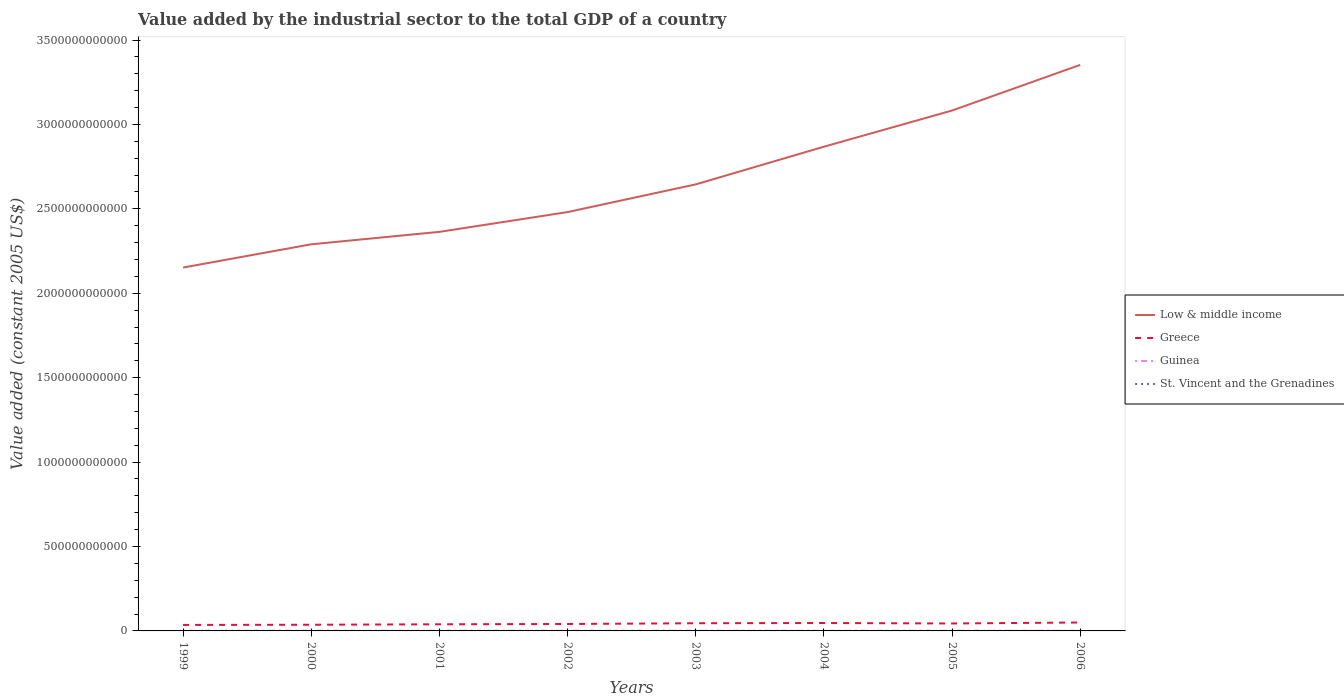How many different coloured lines are there?
Ensure brevity in your answer.  4. Does the line corresponding to Guinea intersect with the line corresponding to Greece?
Ensure brevity in your answer.  No. Is the number of lines equal to the number of legend labels?
Give a very brief answer. Yes. Across all years, what is the maximum value added by the industrial sector in Guinea?
Provide a succinct answer. 7.63e+08. In which year was the value added by the industrial sector in Guinea maximum?
Your answer should be compact. 1999. What is the total value added by the industrial sector in Guinea in the graph?
Give a very brief answer. -8.43e+07. What is the difference between the highest and the second highest value added by the industrial sector in St. Vincent and the Grenadines?
Ensure brevity in your answer.  2.52e+07. What is the difference between the highest and the lowest value added by the industrial sector in Greece?
Offer a terse response. 4. How many lines are there?
Your answer should be compact. 4. What is the difference between two consecutive major ticks on the Y-axis?
Your response must be concise. 5.00e+11. Are the values on the major ticks of Y-axis written in scientific E-notation?
Keep it short and to the point. No. How are the legend labels stacked?
Your response must be concise. Vertical. What is the title of the graph?
Your response must be concise. Value added by the industrial sector to the total GDP of a country. Does "Jamaica" appear as one of the legend labels in the graph?
Provide a short and direct response. No. What is the label or title of the X-axis?
Offer a terse response. Years. What is the label or title of the Y-axis?
Your answer should be very brief. Value added (constant 2005 US$). What is the Value added (constant 2005 US$) of Low & middle income in 1999?
Your response must be concise. 2.15e+12. What is the Value added (constant 2005 US$) in Greece in 1999?
Ensure brevity in your answer.  3.55e+1. What is the Value added (constant 2005 US$) of Guinea in 1999?
Your answer should be very brief. 7.63e+08. What is the Value added (constant 2005 US$) in St. Vincent and the Grenadines in 1999?
Ensure brevity in your answer.  7.55e+07. What is the Value added (constant 2005 US$) of Low & middle income in 2000?
Make the answer very short. 2.29e+12. What is the Value added (constant 2005 US$) in Greece in 2000?
Give a very brief answer. 3.66e+1. What is the Value added (constant 2005 US$) in Guinea in 2000?
Ensure brevity in your answer.  7.97e+08. What is the Value added (constant 2005 US$) in St. Vincent and the Grenadines in 2000?
Make the answer very short. 6.92e+07. What is the Value added (constant 2005 US$) of Low & middle income in 2001?
Your response must be concise. 2.36e+12. What is the Value added (constant 2005 US$) of Greece in 2001?
Your answer should be very brief. 3.93e+1. What is the Value added (constant 2005 US$) of Guinea in 2001?
Provide a succinct answer. 8.38e+08. What is the Value added (constant 2005 US$) of St. Vincent and the Grenadines in 2001?
Your answer should be compact. 7.03e+07. What is the Value added (constant 2005 US$) of Low & middle income in 2002?
Your answer should be compact. 2.48e+12. What is the Value added (constant 2005 US$) in Greece in 2002?
Provide a succinct answer. 4.10e+1. What is the Value added (constant 2005 US$) of Guinea in 2002?
Provide a short and direct response. 8.80e+08. What is the Value added (constant 2005 US$) in St. Vincent and the Grenadines in 2002?
Your response must be concise. 7.29e+07. What is the Value added (constant 2005 US$) of Low & middle income in 2003?
Your answer should be compact. 2.65e+12. What is the Value added (constant 2005 US$) of Greece in 2003?
Your answer should be very brief. 4.55e+1. What is the Value added (constant 2005 US$) in Guinea in 2003?
Your answer should be compact. 8.81e+08. What is the Value added (constant 2005 US$) in St. Vincent and the Grenadines in 2003?
Keep it short and to the point. 8.26e+07. What is the Value added (constant 2005 US$) of Low & middle income in 2004?
Provide a succinct answer. 2.87e+12. What is the Value added (constant 2005 US$) of Greece in 2004?
Offer a very short reply. 4.68e+1. What is the Value added (constant 2005 US$) of Guinea in 2004?
Give a very brief answer. 9.08e+08. What is the Value added (constant 2005 US$) of St. Vincent and the Grenadines in 2004?
Your answer should be compact. 8.74e+07. What is the Value added (constant 2005 US$) in Low & middle income in 2005?
Offer a terse response. 3.08e+12. What is the Value added (constant 2005 US$) in Greece in 2005?
Offer a very short reply. 4.41e+1. What is the Value added (constant 2005 US$) of Guinea in 2005?
Give a very brief answer. 9.42e+08. What is the Value added (constant 2005 US$) in St. Vincent and the Grenadines in 2005?
Provide a succinct answer. 9.02e+07. What is the Value added (constant 2005 US$) of Low & middle income in 2006?
Offer a terse response. 3.35e+12. What is the Value added (constant 2005 US$) in Greece in 2006?
Provide a short and direct response. 4.99e+1. What is the Value added (constant 2005 US$) in Guinea in 2006?
Offer a terse response. 9.63e+08. What is the Value added (constant 2005 US$) in St. Vincent and the Grenadines in 2006?
Keep it short and to the point. 9.45e+07. Across all years, what is the maximum Value added (constant 2005 US$) of Low & middle income?
Offer a very short reply. 3.35e+12. Across all years, what is the maximum Value added (constant 2005 US$) of Greece?
Your response must be concise. 4.99e+1. Across all years, what is the maximum Value added (constant 2005 US$) in Guinea?
Keep it short and to the point. 9.63e+08. Across all years, what is the maximum Value added (constant 2005 US$) in St. Vincent and the Grenadines?
Provide a short and direct response. 9.45e+07. Across all years, what is the minimum Value added (constant 2005 US$) of Low & middle income?
Your answer should be compact. 2.15e+12. Across all years, what is the minimum Value added (constant 2005 US$) in Greece?
Keep it short and to the point. 3.55e+1. Across all years, what is the minimum Value added (constant 2005 US$) of Guinea?
Offer a very short reply. 7.63e+08. Across all years, what is the minimum Value added (constant 2005 US$) in St. Vincent and the Grenadines?
Your answer should be very brief. 6.92e+07. What is the total Value added (constant 2005 US$) in Low & middle income in the graph?
Provide a short and direct response. 2.12e+13. What is the total Value added (constant 2005 US$) of Greece in the graph?
Give a very brief answer. 3.39e+11. What is the total Value added (constant 2005 US$) of Guinea in the graph?
Your answer should be compact. 6.97e+09. What is the total Value added (constant 2005 US$) in St. Vincent and the Grenadines in the graph?
Offer a terse response. 6.43e+08. What is the difference between the Value added (constant 2005 US$) in Low & middle income in 1999 and that in 2000?
Offer a terse response. -1.38e+11. What is the difference between the Value added (constant 2005 US$) of Greece in 1999 and that in 2000?
Provide a succinct answer. -1.05e+09. What is the difference between the Value added (constant 2005 US$) in Guinea in 1999 and that in 2000?
Keep it short and to the point. -3.36e+07. What is the difference between the Value added (constant 2005 US$) of St. Vincent and the Grenadines in 1999 and that in 2000?
Offer a terse response. 6.26e+06. What is the difference between the Value added (constant 2005 US$) in Low & middle income in 1999 and that in 2001?
Your answer should be very brief. -2.11e+11. What is the difference between the Value added (constant 2005 US$) in Greece in 1999 and that in 2001?
Offer a very short reply. -3.78e+09. What is the difference between the Value added (constant 2005 US$) of Guinea in 1999 and that in 2001?
Provide a succinct answer. -7.47e+07. What is the difference between the Value added (constant 2005 US$) of St. Vincent and the Grenadines in 1999 and that in 2001?
Your answer should be compact. 5.14e+06. What is the difference between the Value added (constant 2005 US$) in Low & middle income in 1999 and that in 2002?
Keep it short and to the point. -3.29e+11. What is the difference between the Value added (constant 2005 US$) in Greece in 1999 and that in 2002?
Give a very brief answer. -5.54e+09. What is the difference between the Value added (constant 2005 US$) of Guinea in 1999 and that in 2002?
Offer a terse response. -1.17e+08. What is the difference between the Value added (constant 2005 US$) of St. Vincent and the Grenadines in 1999 and that in 2002?
Your answer should be compact. 2.57e+06. What is the difference between the Value added (constant 2005 US$) of Low & middle income in 1999 and that in 2003?
Provide a short and direct response. -4.93e+11. What is the difference between the Value added (constant 2005 US$) of Greece in 1999 and that in 2003?
Your answer should be very brief. -9.99e+09. What is the difference between the Value added (constant 2005 US$) of Guinea in 1999 and that in 2003?
Your answer should be very brief. -1.18e+08. What is the difference between the Value added (constant 2005 US$) in St. Vincent and the Grenadines in 1999 and that in 2003?
Your answer should be very brief. -7.10e+06. What is the difference between the Value added (constant 2005 US$) of Low & middle income in 1999 and that in 2004?
Ensure brevity in your answer.  -7.16e+11. What is the difference between the Value added (constant 2005 US$) of Greece in 1999 and that in 2004?
Keep it short and to the point. -1.13e+1. What is the difference between the Value added (constant 2005 US$) in Guinea in 1999 and that in 2004?
Make the answer very short. -1.44e+08. What is the difference between the Value added (constant 2005 US$) of St. Vincent and the Grenadines in 1999 and that in 2004?
Keep it short and to the point. -1.19e+07. What is the difference between the Value added (constant 2005 US$) in Low & middle income in 1999 and that in 2005?
Provide a succinct answer. -9.30e+11. What is the difference between the Value added (constant 2005 US$) in Greece in 1999 and that in 2005?
Offer a very short reply. -8.61e+09. What is the difference between the Value added (constant 2005 US$) in Guinea in 1999 and that in 2005?
Ensure brevity in your answer.  -1.78e+08. What is the difference between the Value added (constant 2005 US$) of St. Vincent and the Grenadines in 1999 and that in 2005?
Your answer should be compact. -1.48e+07. What is the difference between the Value added (constant 2005 US$) in Low & middle income in 1999 and that in 2006?
Offer a terse response. -1.20e+12. What is the difference between the Value added (constant 2005 US$) in Greece in 1999 and that in 2006?
Your answer should be compact. -1.44e+1. What is the difference between the Value added (constant 2005 US$) in Guinea in 1999 and that in 2006?
Your answer should be very brief. -2.00e+08. What is the difference between the Value added (constant 2005 US$) in St. Vincent and the Grenadines in 1999 and that in 2006?
Give a very brief answer. -1.90e+07. What is the difference between the Value added (constant 2005 US$) in Low & middle income in 2000 and that in 2001?
Provide a succinct answer. -7.37e+1. What is the difference between the Value added (constant 2005 US$) in Greece in 2000 and that in 2001?
Make the answer very short. -2.73e+09. What is the difference between the Value added (constant 2005 US$) in Guinea in 2000 and that in 2001?
Your response must be concise. -4.10e+07. What is the difference between the Value added (constant 2005 US$) of St. Vincent and the Grenadines in 2000 and that in 2001?
Ensure brevity in your answer.  -1.12e+06. What is the difference between the Value added (constant 2005 US$) in Low & middle income in 2000 and that in 2002?
Your answer should be very brief. -1.91e+11. What is the difference between the Value added (constant 2005 US$) of Greece in 2000 and that in 2002?
Make the answer very short. -4.49e+09. What is the difference between the Value added (constant 2005 US$) in Guinea in 2000 and that in 2002?
Your answer should be very brief. -8.36e+07. What is the difference between the Value added (constant 2005 US$) in St. Vincent and the Grenadines in 2000 and that in 2002?
Give a very brief answer. -3.69e+06. What is the difference between the Value added (constant 2005 US$) in Low & middle income in 2000 and that in 2003?
Provide a short and direct response. -3.55e+11. What is the difference between the Value added (constant 2005 US$) in Greece in 2000 and that in 2003?
Your answer should be compact. -8.93e+09. What is the difference between the Value added (constant 2005 US$) in Guinea in 2000 and that in 2003?
Offer a terse response. -8.43e+07. What is the difference between the Value added (constant 2005 US$) of St. Vincent and the Grenadines in 2000 and that in 2003?
Offer a terse response. -1.34e+07. What is the difference between the Value added (constant 2005 US$) in Low & middle income in 2000 and that in 2004?
Ensure brevity in your answer.  -5.78e+11. What is the difference between the Value added (constant 2005 US$) of Greece in 2000 and that in 2004?
Provide a short and direct response. -1.03e+1. What is the difference between the Value added (constant 2005 US$) in Guinea in 2000 and that in 2004?
Ensure brevity in your answer.  -1.11e+08. What is the difference between the Value added (constant 2005 US$) in St. Vincent and the Grenadines in 2000 and that in 2004?
Your answer should be compact. -1.82e+07. What is the difference between the Value added (constant 2005 US$) in Low & middle income in 2000 and that in 2005?
Keep it short and to the point. -7.92e+11. What is the difference between the Value added (constant 2005 US$) of Greece in 2000 and that in 2005?
Make the answer very short. -7.56e+09. What is the difference between the Value added (constant 2005 US$) in Guinea in 2000 and that in 2005?
Provide a succinct answer. -1.45e+08. What is the difference between the Value added (constant 2005 US$) of St. Vincent and the Grenadines in 2000 and that in 2005?
Keep it short and to the point. -2.10e+07. What is the difference between the Value added (constant 2005 US$) in Low & middle income in 2000 and that in 2006?
Provide a short and direct response. -1.06e+12. What is the difference between the Value added (constant 2005 US$) of Greece in 2000 and that in 2006?
Offer a very short reply. -1.34e+1. What is the difference between the Value added (constant 2005 US$) of Guinea in 2000 and that in 2006?
Offer a very short reply. -1.66e+08. What is the difference between the Value added (constant 2005 US$) in St. Vincent and the Grenadines in 2000 and that in 2006?
Keep it short and to the point. -2.52e+07. What is the difference between the Value added (constant 2005 US$) in Low & middle income in 2001 and that in 2002?
Ensure brevity in your answer.  -1.17e+11. What is the difference between the Value added (constant 2005 US$) of Greece in 2001 and that in 2002?
Offer a terse response. -1.76e+09. What is the difference between the Value added (constant 2005 US$) of Guinea in 2001 and that in 2002?
Keep it short and to the point. -4.25e+07. What is the difference between the Value added (constant 2005 US$) of St. Vincent and the Grenadines in 2001 and that in 2002?
Your response must be concise. -2.58e+06. What is the difference between the Value added (constant 2005 US$) of Low & middle income in 2001 and that in 2003?
Your answer should be compact. -2.81e+11. What is the difference between the Value added (constant 2005 US$) of Greece in 2001 and that in 2003?
Your response must be concise. -6.21e+09. What is the difference between the Value added (constant 2005 US$) of Guinea in 2001 and that in 2003?
Keep it short and to the point. -4.33e+07. What is the difference between the Value added (constant 2005 US$) in St. Vincent and the Grenadines in 2001 and that in 2003?
Make the answer very short. -1.22e+07. What is the difference between the Value added (constant 2005 US$) of Low & middle income in 2001 and that in 2004?
Your response must be concise. -5.04e+11. What is the difference between the Value added (constant 2005 US$) in Greece in 2001 and that in 2004?
Offer a terse response. -7.56e+09. What is the difference between the Value added (constant 2005 US$) of Guinea in 2001 and that in 2004?
Give a very brief answer. -6.97e+07. What is the difference between the Value added (constant 2005 US$) in St. Vincent and the Grenadines in 2001 and that in 2004?
Your answer should be compact. -1.70e+07. What is the difference between the Value added (constant 2005 US$) of Low & middle income in 2001 and that in 2005?
Your answer should be compact. -7.19e+11. What is the difference between the Value added (constant 2005 US$) of Greece in 2001 and that in 2005?
Give a very brief answer. -4.83e+09. What is the difference between the Value added (constant 2005 US$) in Guinea in 2001 and that in 2005?
Give a very brief answer. -1.04e+08. What is the difference between the Value added (constant 2005 US$) of St. Vincent and the Grenadines in 2001 and that in 2005?
Your answer should be very brief. -1.99e+07. What is the difference between the Value added (constant 2005 US$) in Low & middle income in 2001 and that in 2006?
Offer a terse response. -9.89e+11. What is the difference between the Value added (constant 2005 US$) in Greece in 2001 and that in 2006?
Give a very brief answer. -1.06e+1. What is the difference between the Value added (constant 2005 US$) of Guinea in 2001 and that in 2006?
Your answer should be very brief. -1.25e+08. What is the difference between the Value added (constant 2005 US$) in St. Vincent and the Grenadines in 2001 and that in 2006?
Your answer should be very brief. -2.41e+07. What is the difference between the Value added (constant 2005 US$) of Low & middle income in 2002 and that in 2003?
Your answer should be compact. -1.64e+11. What is the difference between the Value added (constant 2005 US$) of Greece in 2002 and that in 2003?
Offer a very short reply. -4.45e+09. What is the difference between the Value added (constant 2005 US$) of Guinea in 2002 and that in 2003?
Give a very brief answer. -7.42e+05. What is the difference between the Value added (constant 2005 US$) of St. Vincent and the Grenadines in 2002 and that in 2003?
Make the answer very short. -9.67e+06. What is the difference between the Value added (constant 2005 US$) of Low & middle income in 2002 and that in 2004?
Make the answer very short. -3.87e+11. What is the difference between the Value added (constant 2005 US$) of Greece in 2002 and that in 2004?
Your answer should be compact. -5.80e+09. What is the difference between the Value added (constant 2005 US$) in Guinea in 2002 and that in 2004?
Make the answer very short. -2.71e+07. What is the difference between the Value added (constant 2005 US$) in St. Vincent and the Grenadines in 2002 and that in 2004?
Give a very brief answer. -1.45e+07. What is the difference between the Value added (constant 2005 US$) in Low & middle income in 2002 and that in 2005?
Provide a short and direct response. -6.02e+11. What is the difference between the Value added (constant 2005 US$) of Greece in 2002 and that in 2005?
Make the answer very short. -3.07e+09. What is the difference between the Value added (constant 2005 US$) in Guinea in 2002 and that in 2005?
Your response must be concise. -6.12e+07. What is the difference between the Value added (constant 2005 US$) in St. Vincent and the Grenadines in 2002 and that in 2005?
Offer a terse response. -1.73e+07. What is the difference between the Value added (constant 2005 US$) in Low & middle income in 2002 and that in 2006?
Offer a very short reply. -8.72e+11. What is the difference between the Value added (constant 2005 US$) in Greece in 2002 and that in 2006?
Ensure brevity in your answer.  -8.89e+09. What is the difference between the Value added (constant 2005 US$) in Guinea in 2002 and that in 2006?
Keep it short and to the point. -8.27e+07. What is the difference between the Value added (constant 2005 US$) of St. Vincent and the Grenadines in 2002 and that in 2006?
Give a very brief answer. -2.15e+07. What is the difference between the Value added (constant 2005 US$) of Low & middle income in 2003 and that in 2004?
Your response must be concise. -2.23e+11. What is the difference between the Value added (constant 2005 US$) of Greece in 2003 and that in 2004?
Your answer should be very brief. -1.35e+09. What is the difference between the Value added (constant 2005 US$) of Guinea in 2003 and that in 2004?
Keep it short and to the point. -2.64e+07. What is the difference between the Value added (constant 2005 US$) of St. Vincent and the Grenadines in 2003 and that in 2004?
Your answer should be compact. -4.79e+06. What is the difference between the Value added (constant 2005 US$) of Low & middle income in 2003 and that in 2005?
Provide a succinct answer. -4.37e+11. What is the difference between the Value added (constant 2005 US$) in Greece in 2003 and that in 2005?
Provide a succinct answer. 1.38e+09. What is the difference between the Value added (constant 2005 US$) in Guinea in 2003 and that in 2005?
Your answer should be very brief. -6.05e+07. What is the difference between the Value added (constant 2005 US$) in St. Vincent and the Grenadines in 2003 and that in 2005?
Ensure brevity in your answer.  -7.65e+06. What is the difference between the Value added (constant 2005 US$) of Low & middle income in 2003 and that in 2006?
Provide a succinct answer. -7.08e+11. What is the difference between the Value added (constant 2005 US$) in Greece in 2003 and that in 2006?
Make the answer very short. -4.44e+09. What is the difference between the Value added (constant 2005 US$) in Guinea in 2003 and that in 2006?
Your answer should be compact. -8.19e+07. What is the difference between the Value added (constant 2005 US$) of St. Vincent and the Grenadines in 2003 and that in 2006?
Offer a terse response. -1.19e+07. What is the difference between the Value added (constant 2005 US$) in Low & middle income in 2004 and that in 2005?
Give a very brief answer. -2.14e+11. What is the difference between the Value added (constant 2005 US$) in Greece in 2004 and that in 2005?
Your answer should be very brief. 2.73e+09. What is the difference between the Value added (constant 2005 US$) of Guinea in 2004 and that in 2005?
Provide a succinct answer. -3.41e+07. What is the difference between the Value added (constant 2005 US$) in St. Vincent and the Grenadines in 2004 and that in 2005?
Your answer should be very brief. -2.86e+06. What is the difference between the Value added (constant 2005 US$) in Low & middle income in 2004 and that in 2006?
Provide a short and direct response. -4.85e+11. What is the difference between the Value added (constant 2005 US$) in Greece in 2004 and that in 2006?
Provide a short and direct response. -3.09e+09. What is the difference between the Value added (constant 2005 US$) in Guinea in 2004 and that in 2006?
Make the answer very short. -5.55e+07. What is the difference between the Value added (constant 2005 US$) of St. Vincent and the Grenadines in 2004 and that in 2006?
Offer a terse response. -7.08e+06. What is the difference between the Value added (constant 2005 US$) of Low & middle income in 2005 and that in 2006?
Keep it short and to the point. -2.70e+11. What is the difference between the Value added (constant 2005 US$) in Greece in 2005 and that in 2006?
Your answer should be compact. -5.82e+09. What is the difference between the Value added (constant 2005 US$) of Guinea in 2005 and that in 2006?
Your answer should be compact. -2.14e+07. What is the difference between the Value added (constant 2005 US$) in St. Vincent and the Grenadines in 2005 and that in 2006?
Keep it short and to the point. -4.23e+06. What is the difference between the Value added (constant 2005 US$) of Low & middle income in 1999 and the Value added (constant 2005 US$) of Greece in 2000?
Ensure brevity in your answer.  2.12e+12. What is the difference between the Value added (constant 2005 US$) in Low & middle income in 1999 and the Value added (constant 2005 US$) in Guinea in 2000?
Your answer should be very brief. 2.15e+12. What is the difference between the Value added (constant 2005 US$) in Low & middle income in 1999 and the Value added (constant 2005 US$) in St. Vincent and the Grenadines in 2000?
Offer a very short reply. 2.15e+12. What is the difference between the Value added (constant 2005 US$) of Greece in 1999 and the Value added (constant 2005 US$) of Guinea in 2000?
Make the answer very short. 3.47e+1. What is the difference between the Value added (constant 2005 US$) in Greece in 1999 and the Value added (constant 2005 US$) in St. Vincent and the Grenadines in 2000?
Provide a succinct answer. 3.54e+1. What is the difference between the Value added (constant 2005 US$) of Guinea in 1999 and the Value added (constant 2005 US$) of St. Vincent and the Grenadines in 2000?
Provide a succinct answer. 6.94e+08. What is the difference between the Value added (constant 2005 US$) of Low & middle income in 1999 and the Value added (constant 2005 US$) of Greece in 2001?
Keep it short and to the point. 2.11e+12. What is the difference between the Value added (constant 2005 US$) in Low & middle income in 1999 and the Value added (constant 2005 US$) in Guinea in 2001?
Your answer should be compact. 2.15e+12. What is the difference between the Value added (constant 2005 US$) of Low & middle income in 1999 and the Value added (constant 2005 US$) of St. Vincent and the Grenadines in 2001?
Provide a short and direct response. 2.15e+12. What is the difference between the Value added (constant 2005 US$) in Greece in 1999 and the Value added (constant 2005 US$) in Guinea in 2001?
Provide a succinct answer. 3.47e+1. What is the difference between the Value added (constant 2005 US$) of Greece in 1999 and the Value added (constant 2005 US$) of St. Vincent and the Grenadines in 2001?
Provide a succinct answer. 3.54e+1. What is the difference between the Value added (constant 2005 US$) of Guinea in 1999 and the Value added (constant 2005 US$) of St. Vincent and the Grenadines in 2001?
Keep it short and to the point. 6.93e+08. What is the difference between the Value added (constant 2005 US$) of Low & middle income in 1999 and the Value added (constant 2005 US$) of Greece in 2002?
Offer a very short reply. 2.11e+12. What is the difference between the Value added (constant 2005 US$) of Low & middle income in 1999 and the Value added (constant 2005 US$) of Guinea in 2002?
Your answer should be compact. 2.15e+12. What is the difference between the Value added (constant 2005 US$) in Low & middle income in 1999 and the Value added (constant 2005 US$) in St. Vincent and the Grenadines in 2002?
Your answer should be very brief. 2.15e+12. What is the difference between the Value added (constant 2005 US$) of Greece in 1999 and the Value added (constant 2005 US$) of Guinea in 2002?
Make the answer very short. 3.46e+1. What is the difference between the Value added (constant 2005 US$) in Greece in 1999 and the Value added (constant 2005 US$) in St. Vincent and the Grenadines in 2002?
Your answer should be compact. 3.54e+1. What is the difference between the Value added (constant 2005 US$) in Guinea in 1999 and the Value added (constant 2005 US$) in St. Vincent and the Grenadines in 2002?
Offer a very short reply. 6.90e+08. What is the difference between the Value added (constant 2005 US$) of Low & middle income in 1999 and the Value added (constant 2005 US$) of Greece in 2003?
Offer a terse response. 2.11e+12. What is the difference between the Value added (constant 2005 US$) in Low & middle income in 1999 and the Value added (constant 2005 US$) in Guinea in 2003?
Make the answer very short. 2.15e+12. What is the difference between the Value added (constant 2005 US$) of Low & middle income in 1999 and the Value added (constant 2005 US$) of St. Vincent and the Grenadines in 2003?
Your answer should be compact. 2.15e+12. What is the difference between the Value added (constant 2005 US$) in Greece in 1999 and the Value added (constant 2005 US$) in Guinea in 2003?
Provide a short and direct response. 3.46e+1. What is the difference between the Value added (constant 2005 US$) of Greece in 1999 and the Value added (constant 2005 US$) of St. Vincent and the Grenadines in 2003?
Give a very brief answer. 3.54e+1. What is the difference between the Value added (constant 2005 US$) in Guinea in 1999 and the Value added (constant 2005 US$) in St. Vincent and the Grenadines in 2003?
Give a very brief answer. 6.81e+08. What is the difference between the Value added (constant 2005 US$) in Low & middle income in 1999 and the Value added (constant 2005 US$) in Greece in 2004?
Keep it short and to the point. 2.11e+12. What is the difference between the Value added (constant 2005 US$) of Low & middle income in 1999 and the Value added (constant 2005 US$) of Guinea in 2004?
Your answer should be very brief. 2.15e+12. What is the difference between the Value added (constant 2005 US$) in Low & middle income in 1999 and the Value added (constant 2005 US$) in St. Vincent and the Grenadines in 2004?
Give a very brief answer. 2.15e+12. What is the difference between the Value added (constant 2005 US$) in Greece in 1999 and the Value added (constant 2005 US$) in Guinea in 2004?
Give a very brief answer. 3.46e+1. What is the difference between the Value added (constant 2005 US$) of Greece in 1999 and the Value added (constant 2005 US$) of St. Vincent and the Grenadines in 2004?
Your response must be concise. 3.54e+1. What is the difference between the Value added (constant 2005 US$) of Guinea in 1999 and the Value added (constant 2005 US$) of St. Vincent and the Grenadines in 2004?
Your answer should be very brief. 6.76e+08. What is the difference between the Value added (constant 2005 US$) of Low & middle income in 1999 and the Value added (constant 2005 US$) of Greece in 2005?
Make the answer very short. 2.11e+12. What is the difference between the Value added (constant 2005 US$) of Low & middle income in 1999 and the Value added (constant 2005 US$) of Guinea in 2005?
Ensure brevity in your answer.  2.15e+12. What is the difference between the Value added (constant 2005 US$) in Low & middle income in 1999 and the Value added (constant 2005 US$) in St. Vincent and the Grenadines in 2005?
Provide a succinct answer. 2.15e+12. What is the difference between the Value added (constant 2005 US$) of Greece in 1999 and the Value added (constant 2005 US$) of Guinea in 2005?
Your answer should be very brief. 3.46e+1. What is the difference between the Value added (constant 2005 US$) of Greece in 1999 and the Value added (constant 2005 US$) of St. Vincent and the Grenadines in 2005?
Provide a succinct answer. 3.54e+1. What is the difference between the Value added (constant 2005 US$) of Guinea in 1999 and the Value added (constant 2005 US$) of St. Vincent and the Grenadines in 2005?
Provide a short and direct response. 6.73e+08. What is the difference between the Value added (constant 2005 US$) of Low & middle income in 1999 and the Value added (constant 2005 US$) of Greece in 2006?
Give a very brief answer. 2.10e+12. What is the difference between the Value added (constant 2005 US$) in Low & middle income in 1999 and the Value added (constant 2005 US$) in Guinea in 2006?
Offer a very short reply. 2.15e+12. What is the difference between the Value added (constant 2005 US$) of Low & middle income in 1999 and the Value added (constant 2005 US$) of St. Vincent and the Grenadines in 2006?
Offer a terse response. 2.15e+12. What is the difference between the Value added (constant 2005 US$) of Greece in 1999 and the Value added (constant 2005 US$) of Guinea in 2006?
Your answer should be very brief. 3.45e+1. What is the difference between the Value added (constant 2005 US$) in Greece in 1999 and the Value added (constant 2005 US$) in St. Vincent and the Grenadines in 2006?
Your response must be concise. 3.54e+1. What is the difference between the Value added (constant 2005 US$) in Guinea in 1999 and the Value added (constant 2005 US$) in St. Vincent and the Grenadines in 2006?
Offer a terse response. 6.69e+08. What is the difference between the Value added (constant 2005 US$) in Low & middle income in 2000 and the Value added (constant 2005 US$) in Greece in 2001?
Your answer should be compact. 2.25e+12. What is the difference between the Value added (constant 2005 US$) in Low & middle income in 2000 and the Value added (constant 2005 US$) in Guinea in 2001?
Provide a short and direct response. 2.29e+12. What is the difference between the Value added (constant 2005 US$) in Low & middle income in 2000 and the Value added (constant 2005 US$) in St. Vincent and the Grenadines in 2001?
Ensure brevity in your answer.  2.29e+12. What is the difference between the Value added (constant 2005 US$) of Greece in 2000 and the Value added (constant 2005 US$) of Guinea in 2001?
Ensure brevity in your answer.  3.57e+1. What is the difference between the Value added (constant 2005 US$) of Greece in 2000 and the Value added (constant 2005 US$) of St. Vincent and the Grenadines in 2001?
Ensure brevity in your answer.  3.65e+1. What is the difference between the Value added (constant 2005 US$) in Guinea in 2000 and the Value added (constant 2005 US$) in St. Vincent and the Grenadines in 2001?
Offer a very short reply. 7.26e+08. What is the difference between the Value added (constant 2005 US$) in Low & middle income in 2000 and the Value added (constant 2005 US$) in Greece in 2002?
Ensure brevity in your answer.  2.25e+12. What is the difference between the Value added (constant 2005 US$) in Low & middle income in 2000 and the Value added (constant 2005 US$) in Guinea in 2002?
Your answer should be compact. 2.29e+12. What is the difference between the Value added (constant 2005 US$) in Low & middle income in 2000 and the Value added (constant 2005 US$) in St. Vincent and the Grenadines in 2002?
Offer a very short reply. 2.29e+12. What is the difference between the Value added (constant 2005 US$) of Greece in 2000 and the Value added (constant 2005 US$) of Guinea in 2002?
Keep it short and to the point. 3.57e+1. What is the difference between the Value added (constant 2005 US$) of Greece in 2000 and the Value added (constant 2005 US$) of St. Vincent and the Grenadines in 2002?
Give a very brief answer. 3.65e+1. What is the difference between the Value added (constant 2005 US$) of Guinea in 2000 and the Value added (constant 2005 US$) of St. Vincent and the Grenadines in 2002?
Your response must be concise. 7.24e+08. What is the difference between the Value added (constant 2005 US$) in Low & middle income in 2000 and the Value added (constant 2005 US$) in Greece in 2003?
Your answer should be compact. 2.24e+12. What is the difference between the Value added (constant 2005 US$) of Low & middle income in 2000 and the Value added (constant 2005 US$) of Guinea in 2003?
Your response must be concise. 2.29e+12. What is the difference between the Value added (constant 2005 US$) in Low & middle income in 2000 and the Value added (constant 2005 US$) in St. Vincent and the Grenadines in 2003?
Keep it short and to the point. 2.29e+12. What is the difference between the Value added (constant 2005 US$) in Greece in 2000 and the Value added (constant 2005 US$) in Guinea in 2003?
Offer a very short reply. 3.57e+1. What is the difference between the Value added (constant 2005 US$) in Greece in 2000 and the Value added (constant 2005 US$) in St. Vincent and the Grenadines in 2003?
Provide a succinct answer. 3.65e+1. What is the difference between the Value added (constant 2005 US$) in Guinea in 2000 and the Value added (constant 2005 US$) in St. Vincent and the Grenadines in 2003?
Ensure brevity in your answer.  7.14e+08. What is the difference between the Value added (constant 2005 US$) of Low & middle income in 2000 and the Value added (constant 2005 US$) of Greece in 2004?
Give a very brief answer. 2.24e+12. What is the difference between the Value added (constant 2005 US$) of Low & middle income in 2000 and the Value added (constant 2005 US$) of Guinea in 2004?
Offer a very short reply. 2.29e+12. What is the difference between the Value added (constant 2005 US$) of Low & middle income in 2000 and the Value added (constant 2005 US$) of St. Vincent and the Grenadines in 2004?
Provide a succinct answer. 2.29e+12. What is the difference between the Value added (constant 2005 US$) of Greece in 2000 and the Value added (constant 2005 US$) of Guinea in 2004?
Make the answer very short. 3.57e+1. What is the difference between the Value added (constant 2005 US$) of Greece in 2000 and the Value added (constant 2005 US$) of St. Vincent and the Grenadines in 2004?
Your answer should be compact. 3.65e+1. What is the difference between the Value added (constant 2005 US$) of Guinea in 2000 and the Value added (constant 2005 US$) of St. Vincent and the Grenadines in 2004?
Ensure brevity in your answer.  7.09e+08. What is the difference between the Value added (constant 2005 US$) of Low & middle income in 2000 and the Value added (constant 2005 US$) of Greece in 2005?
Keep it short and to the point. 2.25e+12. What is the difference between the Value added (constant 2005 US$) of Low & middle income in 2000 and the Value added (constant 2005 US$) of Guinea in 2005?
Your answer should be very brief. 2.29e+12. What is the difference between the Value added (constant 2005 US$) of Low & middle income in 2000 and the Value added (constant 2005 US$) of St. Vincent and the Grenadines in 2005?
Provide a succinct answer. 2.29e+12. What is the difference between the Value added (constant 2005 US$) in Greece in 2000 and the Value added (constant 2005 US$) in Guinea in 2005?
Keep it short and to the point. 3.56e+1. What is the difference between the Value added (constant 2005 US$) in Greece in 2000 and the Value added (constant 2005 US$) in St. Vincent and the Grenadines in 2005?
Provide a short and direct response. 3.65e+1. What is the difference between the Value added (constant 2005 US$) in Guinea in 2000 and the Value added (constant 2005 US$) in St. Vincent and the Grenadines in 2005?
Offer a terse response. 7.07e+08. What is the difference between the Value added (constant 2005 US$) in Low & middle income in 2000 and the Value added (constant 2005 US$) in Greece in 2006?
Offer a terse response. 2.24e+12. What is the difference between the Value added (constant 2005 US$) in Low & middle income in 2000 and the Value added (constant 2005 US$) in Guinea in 2006?
Your answer should be compact. 2.29e+12. What is the difference between the Value added (constant 2005 US$) of Low & middle income in 2000 and the Value added (constant 2005 US$) of St. Vincent and the Grenadines in 2006?
Provide a short and direct response. 2.29e+12. What is the difference between the Value added (constant 2005 US$) in Greece in 2000 and the Value added (constant 2005 US$) in Guinea in 2006?
Your response must be concise. 3.56e+1. What is the difference between the Value added (constant 2005 US$) of Greece in 2000 and the Value added (constant 2005 US$) of St. Vincent and the Grenadines in 2006?
Offer a terse response. 3.65e+1. What is the difference between the Value added (constant 2005 US$) in Guinea in 2000 and the Value added (constant 2005 US$) in St. Vincent and the Grenadines in 2006?
Offer a terse response. 7.02e+08. What is the difference between the Value added (constant 2005 US$) of Low & middle income in 2001 and the Value added (constant 2005 US$) of Greece in 2002?
Keep it short and to the point. 2.32e+12. What is the difference between the Value added (constant 2005 US$) in Low & middle income in 2001 and the Value added (constant 2005 US$) in Guinea in 2002?
Your response must be concise. 2.36e+12. What is the difference between the Value added (constant 2005 US$) in Low & middle income in 2001 and the Value added (constant 2005 US$) in St. Vincent and the Grenadines in 2002?
Ensure brevity in your answer.  2.36e+12. What is the difference between the Value added (constant 2005 US$) in Greece in 2001 and the Value added (constant 2005 US$) in Guinea in 2002?
Offer a terse response. 3.84e+1. What is the difference between the Value added (constant 2005 US$) of Greece in 2001 and the Value added (constant 2005 US$) of St. Vincent and the Grenadines in 2002?
Offer a terse response. 3.92e+1. What is the difference between the Value added (constant 2005 US$) in Guinea in 2001 and the Value added (constant 2005 US$) in St. Vincent and the Grenadines in 2002?
Your answer should be compact. 7.65e+08. What is the difference between the Value added (constant 2005 US$) in Low & middle income in 2001 and the Value added (constant 2005 US$) in Greece in 2003?
Ensure brevity in your answer.  2.32e+12. What is the difference between the Value added (constant 2005 US$) of Low & middle income in 2001 and the Value added (constant 2005 US$) of Guinea in 2003?
Your response must be concise. 2.36e+12. What is the difference between the Value added (constant 2005 US$) in Low & middle income in 2001 and the Value added (constant 2005 US$) in St. Vincent and the Grenadines in 2003?
Make the answer very short. 2.36e+12. What is the difference between the Value added (constant 2005 US$) in Greece in 2001 and the Value added (constant 2005 US$) in Guinea in 2003?
Provide a short and direct response. 3.84e+1. What is the difference between the Value added (constant 2005 US$) in Greece in 2001 and the Value added (constant 2005 US$) in St. Vincent and the Grenadines in 2003?
Keep it short and to the point. 3.92e+1. What is the difference between the Value added (constant 2005 US$) in Guinea in 2001 and the Value added (constant 2005 US$) in St. Vincent and the Grenadines in 2003?
Your response must be concise. 7.55e+08. What is the difference between the Value added (constant 2005 US$) of Low & middle income in 2001 and the Value added (constant 2005 US$) of Greece in 2004?
Offer a terse response. 2.32e+12. What is the difference between the Value added (constant 2005 US$) of Low & middle income in 2001 and the Value added (constant 2005 US$) of Guinea in 2004?
Make the answer very short. 2.36e+12. What is the difference between the Value added (constant 2005 US$) of Low & middle income in 2001 and the Value added (constant 2005 US$) of St. Vincent and the Grenadines in 2004?
Your answer should be very brief. 2.36e+12. What is the difference between the Value added (constant 2005 US$) in Greece in 2001 and the Value added (constant 2005 US$) in Guinea in 2004?
Give a very brief answer. 3.84e+1. What is the difference between the Value added (constant 2005 US$) of Greece in 2001 and the Value added (constant 2005 US$) of St. Vincent and the Grenadines in 2004?
Offer a terse response. 3.92e+1. What is the difference between the Value added (constant 2005 US$) in Guinea in 2001 and the Value added (constant 2005 US$) in St. Vincent and the Grenadines in 2004?
Provide a succinct answer. 7.50e+08. What is the difference between the Value added (constant 2005 US$) in Low & middle income in 2001 and the Value added (constant 2005 US$) in Greece in 2005?
Offer a terse response. 2.32e+12. What is the difference between the Value added (constant 2005 US$) of Low & middle income in 2001 and the Value added (constant 2005 US$) of Guinea in 2005?
Give a very brief answer. 2.36e+12. What is the difference between the Value added (constant 2005 US$) of Low & middle income in 2001 and the Value added (constant 2005 US$) of St. Vincent and the Grenadines in 2005?
Make the answer very short. 2.36e+12. What is the difference between the Value added (constant 2005 US$) in Greece in 2001 and the Value added (constant 2005 US$) in Guinea in 2005?
Offer a very short reply. 3.83e+1. What is the difference between the Value added (constant 2005 US$) in Greece in 2001 and the Value added (constant 2005 US$) in St. Vincent and the Grenadines in 2005?
Offer a terse response. 3.92e+1. What is the difference between the Value added (constant 2005 US$) in Guinea in 2001 and the Value added (constant 2005 US$) in St. Vincent and the Grenadines in 2005?
Provide a short and direct response. 7.48e+08. What is the difference between the Value added (constant 2005 US$) in Low & middle income in 2001 and the Value added (constant 2005 US$) in Greece in 2006?
Your answer should be compact. 2.31e+12. What is the difference between the Value added (constant 2005 US$) of Low & middle income in 2001 and the Value added (constant 2005 US$) of Guinea in 2006?
Your answer should be very brief. 2.36e+12. What is the difference between the Value added (constant 2005 US$) in Low & middle income in 2001 and the Value added (constant 2005 US$) in St. Vincent and the Grenadines in 2006?
Provide a short and direct response. 2.36e+12. What is the difference between the Value added (constant 2005 US$) in Greece in 2001 and the Value added (constant 2005 US$) in Guinea in 2006?
Provide a short and direct response. 3.83e+1. What is the difference between the Value added (constant 2005 US$) of Greece in 2001 and the Value added (constant 2005 US$) of St. Vincent and the Grenadines in 2006?
Offer a terse response. 3.92e+1. What is the difference between the Value added (constant 2005 US$) of Guinea in 2001 and the Value added (constant 2005 US$) of St. Vincent and the Grenadines in 2006?
Your response must be concise. 7.43e+08. What is the difference between the Value added (constant 2005 US$) of Low & middle income in 2002 and the Value added (constant 2005 US$) of Greece in 2003?
Provide a succinct answer. 2.44e+12. What is the difference between the Value added (constant 2005 US$) of Low & middle income in 2002 and the Value added (constant 2005 US$) of Guinea in 2003?
Your response must be concise. 2.48e+12. What is the difference between the Value added (constant 2005 US$) in Low & middle income in 2002 and the Value added (constant 2005 US$) in St. Vincent and the Grenadines in 2003?
Give a very brief answer. 2.48e+12. What is the difference between the Value added (constant 2005 US$) in Greece in 2002 and the Value added (constant 2005 US$) in Guinea in 2003?
Your response must be concise. 4.02e+1. What is the difference between the Value added (constant 2005 US$) in Greece in 2002 and the Value added (constant 2005 US$) in St. Vincent and the Grenadines in 2003?
Ensure brevity in your answer.  4.10e+1. What is the difference between the Value added (constant 2005 US$) in Guinea in 2002 and the Value added (constant 2005 US$) in St. Vincent and the Grenadines in 2003?
Give a very brief answer. 7.98e+08. What is the difference between the Value added (constant 2005 US$) of Low & middle income in 2002 and the Value added (constant 2005 US$) of Greece in 2004?
Offer a terse response. 2.43e+12. What is the difference between the Value added (constant 2005 US$) of Low & middle income in 2002 and the Value added (constant 2005 US$) of Guinea in 2004?
Offer a terse response. 2.48e+12. What is the difference between the Value added (constant 2005 US$) of Low & middle income in 2002 and the Value added (constant 2005 US$) of St. Vincent and the Grenadines in 2004?
Make the answer very short. 2.48e+12. What is the difference between the Value added (constant 2005 US$) of Greece in 2002 and the Value added (constant 2005 US$) of Guinea in 2004?
Ensure brevity in your answer.  4.01e+1. What is the difference between the Value added (constant 2005 US$) of Greece in 2002 and the Value added (constant 2005 US$) of St. Vincent and the Grenadines in 2004?
Give a very brief answer. 4.10e+1. What is the difference between the Value added (constant 2005 US$) of Guinea in 2002 and the Value added (constant 2005 US$) of St. Vincent and the Grenadines in 2004?
Give a very brief answer. 7.93e+08. What is the difference between the Value added (constant 2005 US$) in Low & middle income in 2002 and the Value added (constant 2005 US$) in Greece in 2005?
Give a very brief answer. 2.44e+12. What is the difference between the Value added (constant 2005 US$) in Low & middle income in 2002 and the Value added (constant 2005 US$) in Guinea in 2005?
Make the answer very short. 2.48e+12. What is the difference between the Value added (constant 2005 US$) of Low & middle income in 2002 and the Value added (constant 2005 US$) of St. Vincent and the Grenadines in 2005?
Provide a succinct answer. 2.48e+12. What is the difference between the Value added (constant 2005 US$) in Greece in 2002 and the Value added (constant 2005 US$) in Guinea in 2005?
Offer a very short reply. 4.01e+1. What is the difference between the Value added (constant 2005 US$) of Greece in 2002 and the Value added (constant 2005 US$) of St. Vincent and the Grenadines in 2005?
Your answer should be very brief. 4.10e+1. What is the difference between the Value added (constant 2005 US$) in Guinea in 2002 and the Value added (constant 2005 US$) in St. Vincent and the Grenadines in 2005?
Your answer should be compact. 7.90e+08. What is the difference between the Value added (constant 2005 US$) in Low & middle income in 2002 and the Value added (constant 2005 US$) in Greece in 2006?
Provide a succinct answer. 2.43e+12. What is the difference between the Value added (constant 2005 US$) in Low & middle income in 2002 and the Value added (constant 2005 US$) in Guinea in 2006?
Your response must be concise. 2.48e+12. What is the difference between the Value added (constant 2005 US$) in Low & middle income in 2002 and the Value added (constant 2005 US$) in St. Vincent and the Grenadines in 2006?
Ensure brevity in your answer.  2.48e+12. What is the difference between the Value added (constant 2005 US$) of Greece in 2002 and the Value added (constant 2005 US$) of Guinea in 2006?
Keep it short and to the point. 4.01e+1. What is the difference between the Value added (constant 2005 US$) of Greece in 2002 and the Value added (constant 2005 US$) of St. Vincent and the Grenadines in 2006?
Make the answer very short. 4.10e+1. What is the difference between the Value added (constant 2005 US$) of Guinea in 2002 and the Value added (constant 2005 US$) of St. Vincent and the Grenadines in 2006?
Give a very brief answer. 7.86e+08. What is the difference between the Value added (constant 2005 US$) in Low & middle income in 2003 and the Value added (constant 2005 US$) in Greece in 2004?
Your answer should be very brief. 2.60e+12. What is the difference between the Value added (constant 2005 US$) of Low & middle income in 2003 and the Value added (constant 2005 US$) of Guinea in 2004?
Your answer should be very brief. 2.64e+12. What is the difference between the Value added (constant 2005 US$) of Low & middle income in 2003 and the Value added (constant 2005 US$) of St. Vincent and the Grenadines in 2004?
Keep it short and to the point. 2.65e+12. What is the difference between the Value added (constant 2005 US$) of Greece in 2003 and the Value added (constant 2005 US$) of Guinea in 2004?
Your answer should be compact. 4.46e+1. What is the difference between the Value added (constant 2005 US$) of Greece in 2003 and the Value added (constant 2005 US$) of St. Vincent and the Grenadines in 2004?
Make the answer very short. 4.54e+1. What is the difference between the Value added (constant 2005 US$) of Guinea in 2003 and the Value added (constant 2005 US$) of St. Vincent and the Grenadines in 2004?
Ensure brevity in your answer.  7.94e+08. What is the difference between the Value added (constant 2005 US$) of Low & middle income in 2003 and the Value added (constant 2005 US$) of Greece in 2005?
Give a very brief answer. 2.60e+12. What is the difference between the Value added (constant 2005 US$) of Low & middle income in 2003 and the Value added (constant 2005 US$) of Guinea in 2005?
Provide a short and direct response. 2.64e+12. What is the difference between the Value added (constant 2005 US$) of Low & middle income in 2003 and the Value added (constant 2005 US$) of St. Vincent and the Grenadines in 2005?
Your answer should be compact. 2.65e+12. What is the difference between the Value added (constant 2005 US$) of Greece in 2003 and the Value added (constant 2005 US$) of Guinea in 2005?
Your answer should be compact. 4.46e+1. What is the difference between the Value added (constant 2005 US$) in Greece in 2003 and the Value added (constant 2005 US$) in St. Vincent and the Grenadines in 2005?
Your answer should be compact. 4.54e+1. What is the difference between the Value added (constant 2005 US$) of Guinea in 2003 and the Value added (constant 2005 US$) of St. Vincent and the Grenadines in 2005?
Offer a terse response. 7.91e+08. What is the difference between the Value added (constant 2005 US$) in Low & middle income in 2003 and the Value added (constant 2005 US$) in Greece in 2006?
Your answer should be very brief. 2.60e+12. What is the difference between the Value added (constant 2005 US$) of Low & middle income in 2003 and the Value added (constant 2005 US$) of Guinea in 2006?
Provide a succinct answer. 2.64e+12. What is the difference between the Value added (constant 2005 US$) in Low & middle income in 2003 and the Value added (constant 2005 US$) in St. Vincent and the Grenadines in 2006?
Your answer should be compact. 2.65e+12. What is the difference between the Value added (constant 2005 US$) in Greece in 2003 and the Value added (constant 2005 US$) in Guinea in 2006?
Your response must be concise. 4.45e+1. What is the difference between the Value added (constant 2005 US$) in Greece in 2003 and the Value added (constant 2005 US$) in St. Vincent and the Grenadines in 2006?
Offer a terse response. 4.54e+1. What is the difference between the Value added (constant 2005 US$) of Guinea in 2003 and the Value added (constant 2005 US$) of St. Vincent and the Grenadines in 2006?
Your response must be concise. 7.87e+08. What is the difference between the Value added (constant 2005 US$) in Low & middle income in 2004 and the Value added (constant 2005 US$) in Greece in 2005?
Ensure brevity in your answer.  2.82e+12. What is the difference between the Value added (constant 2005 US$) in Low & middle income in 2004 and the Value added (constant 2005 US$) in Guinea in 2005?
Your response must be concise. 2.87e+12. What is the difference between the Value added (constant 2005 US$) in Low & middle income in 2004 and the Value added (constant 2005 US$) in St. Vincent and the Grenadines in 2005?
Make the answer very short. 2.87e+12. What is the difference between the Value added (constant 2005 US$) in Greece in 2004 and the Value added (constant 2005 US$) in Guinea in 2005?
Your answer should be compact. 4.59e+1. What is the difference between the Value added (constant 2005 US$) in Greece in 2004 and the Value added (constant 2005 US$) in St. Vincent and the Grenadines in 2005?
Your answer should be very brief. 4.68e+1. What is the difference between the Value added (constant 2005 US$) of Guinea in 2004 and the Value added (constant 2005 US$) of St. Vincent and the Grenadines in 2005?
Give a very brief answer. 8.17e+08. What is the difference between the Value added (constant 2005 US$) of Low & middle income in 2004 and the Value added (constant 2005 US$) of Greece in 2006?
Ensure brevity in your answer.  2.82e+12. What is the difference between the Value added (constant 2005 US$) in Low & middle income in 2004 and the Value added (constant 2005 US$) in Guinea in 2006?
Your response must be concise. 2.87e+12. What is the difference between the Value added (constant 2005 US$) of Low & middle income in 2004 and the Value added (constant 2005 US$) of St. Vincent and the Grenadines in 2006?
Give a very brief answer. 2.87e+12. What is the difference between the Value added (constant 2005 US$) in Greece in 2004 and the Value added (constant 2005 US$) in Guinea in 2006?
Provide a short and direct response. 4.59e+1. What is the difference between the Value added (constant 2005 US$) in Greece in 2004 and the Value added (constant 2005 US$) in St. Vincent and the Grenadines in 2006?
Provide a succinct answer. 4.68e+1. What is the difference between the Value added (constant 2005 US$) in Guinea in 2004 and the Value added (constant 2005 US$) in St. Vincent and the Grenadines in 2006?
Provide a succinct answer. 8.13e+08. What is the difference between the Value added (constant 2005 US$) in Low & middle income in 2005 and the Value added (constant 2005 US$) in Greece in 2006?
Your response must be concise. 3.03e+12. What is the difference between the Value added (constant 2005 US$) in Low & middle income in 2005 and the Value added (constant 2005 US$) in Guinea in 2006?
Offer a very short reply. 3.08e+12. What is the difference between the Value added (constant 2005 US$) in Low & middle income in 2005 and the Value added (constant 2005 US$) in St. Vincent and the Grenadines in 2006?
Provide a short and direct response. 3.08e+12. What is the difference between the Value added (constant 2005 US$) in Greece in 2005 and the Value added (constant 2005 US$) in Guinea in 2006?
Provide a succinct answer. 4.32e+1. What is the difference between the Value added (constant 2005 US$) in Greece in 2005 and the Value added (constant 2005 US$) in St. Vincent and the Grenadines in 2006?
Provide a succinct answer. 4.40e+1. What is the difference between the Value added (constant 2005 US$) in Guinea in 2005 and the Value added (constant 2005 US$) in St. Vincent and the Grenadines in 2006?
Make the answer very short. 8.47e+08. What is the average Value added (constant 2005 US$) of Low & middle income per year?
Your response must be concise. 2.65e+12. What is the average Value added (constant 2005 US$) in Greece per year?
Your response must be concise. 4.23e+1. What is the average Value added (constant 2005 US$) of Guinea per year?
Make the answer very short. 8.71e+08. What is the average Value added (constant 2005 US$) of St. Vincent and the Grenadines per year?
Provide a short and direct response. 8.03e+07. In the year 1999, what is the difference between the Value added (constant 2005 US$) of Low & middle income and Value added (constant 2005 US$) of Greece?
Give a very brief answer. 2.12e+12. In the year 1999, what is the difference between the Value added (constant 2005 US$) of Low & middle income and Value added (constant 2005 US$) of Guinea?
Offer a terse response. 2.15e+12. In the year 1999, what is the difference between the Value added (constant 2005 US$) in Low & middle income and Value added (constant 2005 US$) in St. Vincent and the Grenadines?
Your answer should be compact. 2.15e+12. In the year 1999, what is the difference between the Value added (constant 2005 US$) in Greece and Value added (constant 2005 US$) in Guinea?
Ensure brevity in your answer.  3.47e+1. In the year 1999, what is the difference between the Value added (constant 2005 US$) in Greece and Value added (constant 2005 US$) in St. Vincent and the Grenadines?
Ensure brevity in your answer.  3.54e+1. In the year 1999, what is the difference between the Value added (constant 2005 US$) in Guinea and Value added (constant 2005 US$) in St. Vincent and the Grenadines?
Ensure brevity in your answer.  6.88e+08. In the year 2000, what is the difference between the Value added (constant 2005 US$) in Low & middle income and Value added (constant 2005 US$) in Greece?
Your answer should be very brief. 2.25e+12. In the year 2000, what is the difference between the Value added (constant 2005 US$) of Low & middle income and Value added (constant 2005 US$) of Guinea?
Your response must be concise. 2.29e+12. In the year 2000, what is the difference between the Value added (constant 2005 US$) of Low & middle income and Value added (constant 2005 US$) of St. Vincent and the Grenadines?
Give a very brief answer. 2.29e+12. In the year 2000, what is the difference between the Value added (constant 2005 US$) in Greece and Value added (constant 2005 US$) in Guinea?
Provide a short and direct response. 3.58e+1. In the year 2000, what is the difference between the Value added (constant 2005 US$) of Greece and Value added (constant 2005 US$) of St. Vincent and the Grenadines?
Your answer should be very brief. 3.65e+1. In the year 2000, what is the difference between the Value added (constant 2005 US$) in Guinea and Value added (constant 2005 US$) in St. Vincent and the Grenadines?
Offer a very short reply. 7.28e+08. In the year 2001, what is the difference between the Value added (constant 2005 US$) of Low & middle income and Value added (constant 2005 US$) of Greece?
Offer a terse response. 2.32e+12. In the year 2001, what is the difference between the Value added (constant 2005 US$) of Low & middle income and Value added (constant 2005 US$) of Guinea?
Keep it short and to the point. 2.36e+12. In the year 2001, what is the difference between the Value added (constant 2005 US$) of Low & middle income and Value added (constant 2005 US$) of St. Vincent and the Grenadines?
Provide a succinct answer. 2.36e+12. In the year 2001, what is the difference between the Value added (constant 2005 US$) in Greece and Value added (constant 2005 US$) in Guinea?
Offer a terse response. 3.84e+1. In the year 2001, what is the difference between the Value added (constant 2005 US$) of Greece and Value added (constant 2005 US$) of St. Vincent and the Grenadines?
Provide a short and direct response. 3.92e+1. In the year 2001, what is the difference between the Value added (constant 2005 US$) in Guinea and Value added (constant 2005 US$) in St. Vincent and the Grenadines?
Offer a very short reply. 7.68e+08. In the year 2002, what is the difference between the Value added (constant 2005 US$) of Low & middle income and Value added (constant 2005 US$) of Greece?
Offer a very short reply. 2.44e+12. In the year 2002, what is the difference between the Value added (constant 2005 US$) in Low & middle income and Value added (constant 2005 US$) in Guinea?
Your response must be concise. 2.48e+12. In the year 2002, what is the difference between the Value added (constant 2005 US$) of Low & middle income and Value added (constant 2005 US$) of St. Vincent and the Grenadines?
Offer a very short reply. 2.48e+12. In the year 2002, what is the difference between the Value added (constant 2005 US$) of Greece and Value added (constant 2005 US$) of Guinea?
Your answer should be very brief. 4.02e+1. In the year 2002, what is the difference between the Value added (constant 2005 US$) of Greece and Value added (constant 2005 US$) of St. Vincent and the Grenadines?
Ensure brevity in your answer.  4.10e+1. In the year 2002, what is the difference between the Value added (constant 2005 US$) in Guinea and Value added (constant 2005 US$) in St. Vincent and the Grenadines?
Offer a terse response. 8.07e+08. In the year 2003, what is the difference between the Value added (constant 2005 US$) in Low & middle income and Value added (constant 2005 US$) in Greece?
Provide a succinct answer. 2.60e+12. In the year 2003, what is the difference between the Value added (constant 2005 US$) of Low & middle income and Value added (constant 2005 US$) of Guinea?
Provide a succinct answer. 2.64e+12. In the year 2003, what is the difference between the Value added (constant 2005 US$) in Low & middle income and Value added (constant 2005 US$) in St. Vincent and the Grenadines?
Ensure brevity in your answer.  2.65e+12. In the year 2003, what is the difference between the Value added (constant 2005 US$) of Greece and Value added (constant 2005 US$) of Guinea?
Give a very brief answer. 4.46e+1. In the year 2003, what is the difference between the Value added (constant 2005 US$) in Greece and Value added (constant 2005 US$) in St. Vincent and the Grenadines?
Your response must be concise. 4.54e+1. In the year 2003, what is the difference between the Value added (constant 2005 US$) in Guinea and Value added (constant 2005 US$) in St. Vincent and the Grenadines?
Make the answer very short. 7.99e+08. In the year 2004, what is the difference between the Value added (constant 2005 US$) in Low & middle income and Value added (constant 2005 US$) in Greece?
Offer a very short reply. 2.82e+12. In the year 2004, what is the difference between the Value added (constant 2005 US$) of Low & middle income and Value added (constant 2005 US$) of Guinea?
Give a very brief answer. 2.87e+12. In the year 2004, what is the difference between the Value added (constant 2005 US$) in Low & middle income and Value added (constant 2005 US$) in St. Vincent and the Grenadines?
Provide a succinct answer. 2.87e+12. In the year 2004, what is the difference between the Value added (constant 2005 US$) in Greece and Value added (constant 2005 US$) in Guinea?
Your answer should be very brief. 4.59e+1. In the year 2004, what is the difference between the Value added (constant 2005 US$) of Greece and Value added (constant 2005 US$) of St. Vincent and the Grenadines?
Your answer should be very brief. 4.68e+1. In the year 2004, what is the difference between the Value added (constant 2005 US$) of Guinea and Value added (constant 2005 US$) of St. Vincent and the Grenadines?
Your answer should be very brief. 8.20e+08. In the year 2005, what is the difference between the Value added (constant 2005 US$) of Low & middle income and Value added (constant 2005 US$) of Greece?
Offer a very short reply. 3.04e+12. In the year 2005, what is the difference between the Value added (constant 2005 US$) in Low & middle income and Value added (constant 2005 US$) in Guinea?
Provide a short and direct response. 3.08e+12. In the year 2005, what is the difference between the Value added (constant 2005 US$) of Low & middle income and Value added (constant 2005 US$) of St. Vincent and the Grenadines?
Keep it short and to the point. 3.08e+12. In the year 2005, what is the difference between the Value added (constant 2005 US$) of Greece and Value added (constant 2005 US$) of Guinea?
Your answer should be very brief. 4.32e+1. In the year 2005, what is the difference between the Value added (constant 2005 US$) of Greece and Value added (constant 2005 US$) of St. Vincent and the Grenadines?
Offer a very short reply. 4.40e+1. In the year 2005, what is the difference between the Value added (constant 2005 US$) of Guinea and Value added (constant 2005 US$) of St. Vincent and the Grenadines?
Ensure brevity in your answer.  8.51e+08. In the year 2006, what is the difference between the Value added (constant 2005 US$) of Low & middle income and Value added (constant 2005 US$) of Greece?
Keep it short and to the point. 3.30e+12. In the year 2006, what is the difference between the Value added (constant 2005 US$) of Low & middle income and Value added (constant 2005 US$) of Guinea?
Your answer should be very brief. 3.35e+12. In the year 2006, what is the difference between the Value added (constant 2005 US$) in Low & middle income and Value added (constant 2005 US$) in St. Vincent and the Grenadines?
Ensure brevity in your answer.  3.35e+12. In the year 2006, what is the difference between the Value added (constant 2005 US$) of Greece and Value added (constant 2005 US$) of Guinea?
Ensure brevity in your answer.  4.90e+1. In the year 2006, what is the difference between the Value added (constant 2005 US$) in Greece and Value added (constant 2005 US$) in St. Vincent and the Grenadines?
Keep it short and to the point. 4.98e+1. In the year 2006, what is the difference between the Value added (constant 2005 US$) in Guinea and Value added (constant 2005 US$) in St. Vincent and the Grenadines?
Keep it short and to the point. 8.69e+08. What is the ratio of the Value added (constant 2005 US$) of Low & middle income in 1999 to that in 2000?
Your response must be concise. 0.94. What is the ratio of the Value added (constant 2005 US$) in Greece in 1999 to that in 2000?
Offer a terse response. 0.97. What is the ratio of the Value added (constant 2005 US$) in Guinea in 1999 to that in 2000?
Your answer should be very brief. 0.96. What is the ratio of the Value added (constant 2005 US$) of St. Vincent and the Grenadines in 1999 to that in 2000?
Ensure brevity in your answer.  1.09. What is the ratio of the Value added (constant 2005 US$) of Low & middle income in 1999 to that in 2001?
Offer a terse response. 0.91. What is the ratio of the Value added (constant 2005 US$) of Greece in 1999 to that in 2001?
Offer a very short reply. 0.9. What is the ratio of the Value added (constant 2005 US$) in Guinea in 1999 to that in 2001?
Offer a terse response. 0.91. What is the ratio of the Value added (constant 2005 US$) in St. Vincent and the Grenadines in 1999 to that in 2001?
Offer a terse response. 1.07. What is the ratio of the Value added (constant 2005 US$) in Low & middle income in 1999 to that in 2002?
Offer a terse response. 0.87. What is the ratio of the Value added (constant 2005 US$) in Greece in 1999 to that in 2002?
Keep it short and to the point. 0.87. What is the ratio of the Value added (constant 2005 US$) in Guinea in 1999 to that in 2002?
Ensure brevity in your answer.  0.87. What is the ratio of the Value added (constant 2005 US$) in St. Vincent and the Grenadines in 1999 to that in 2002?
Give a very brief answer. 1.04. What is the ratio of the Value added (constant 2005 US$) of Low & middle income in 1999 to that in 2003?
Give a very brief answer. 0.81. What is the ratio of the Value added (constant 2005 US$) of Greece in 1999 to that in 2003?
Your response must be concise. 0.78. What is the ratio of the Value added (constant 2005 US$) in Guinea in 1999 to that in 2003?
Offer a terse response. 0.87. What is the ratio of the Value added (constant 2005 US$) of St. Vincent and the Grenadines in 1999 to that in 2003?
Your response must be concise. 0.91. What is the ratio of the Value added (constant 2005 US$) in Low & middle income in 1999 to that in 2004?
Provide a short and direct response. 0.75. What is the ratio of the Value added (constant 2005 US$) of Greece in 1999 to that in 2004?
Provide a short and direct response. 0.76. What is the ratio of the Value added (constant 2005 US$) in Guinea in 1999 to that in 2004?
Keep it short and to the point. 0.84. What is the ratio of the Value added (constant 2005 US$) of St. Vincent and the Grenadines in 1999 to that in 2004?
Keep it short and to the point. 0.86. What is the ratio of the Value added (constant 2005 US$) in Low & middle income in 1999 to that in 2005?
Offer a very short reply. 0.7. What is the ratio of the Value added (constant 2005 US$) in Greece in 1999 to that in 2005?
Your answer should be very brief. 0.8. What is the ratio of the Value added (constant 2005 US$) of Guinea in 1999 to that in 2005?
Offer a very short reply. 0.81. What is the ratio of the Value added (constant 2005 US$) in St. Vincent and the Grenadines in 1999 to that in 2005?
Offer a very short reply. 0.84. What is the ratio of the Value added (constant 2005 US$) in Low & middle income in 1999 to that in 2006?
Offer a very short reply. 0.64. What is the ratio of the Value added (constant 2005 US$) of Greece in 1999 to that in 2006?
Ensure brevity in your answer.  0.71. What is the ratio of the Value added (constant 2005 US$) in Guinea in 1999 to that in 2006?
Your answer should be compact. 0.79. What is the ratio of the Value added (constant 2005 US$) of St. Vincent and the Grenadines in 1999 to that in 2006?
Your response must be concise. 0.8. What is the ratio of the Value added (constant 2005 US$) of Low & middle income in 2000 to that in 2001?
Offer a terse response. 0.97. What is the ratio of the Value added (constant 2005 US$) in Greece in 2000 to that in 2001?
Your response must be concise. 0.93. What is the ratio of the Value added (constant 2005 US$) of Guinea in 2000 to that in 2001?
Offer a very short reply. 0.95. What is the ratio of the Value added (constant 2005 US$) in St. Vincent and the Grenadines in 2000 to that in 2001?
Offer a terse response. 0.98. What is the ratio of the Value added (constant 2005 US$) in Low & middle income in 2000 to that in 2002?
Ensure brevity in your answer.  0.92. What is the ratio of the Value added (constant 2005 US$) in Greece in 2000 to that in 2002?
Your response must be concise. 0.89. What is the ratio of the Value added (constant 2005 US$) in Guinea in 2000 to that in 2002?
Your answer should be very brief. 0.91. What is the ratio of the Value added (constant 2005 US$) of St. Vincent and the Grenadines in 2000 to that in 2002?
Provide a short and direct response. 0.95. What is the ratio of the Value added (constant 2005 US$) in Low & middle income in 2000 to that in 2003?
Your answer should be compact. 0.87. What is the ratio of the Value added (constant 2005 US$) of Greece in 2000 to that in 2003?
Keep it short and to the point. 0.8. What is the ratio of the Value added (constant 2005 US$) in Guinea in 2000 to that in 2003?
Provide a succinct answer. 0.9. What is the ratio of the Value added (constant 2005 US$) of St. Vincent and the Grenadines in 2000 to that in 2003?
Your answer should be very brief. 0.84. What is the ratio of the Value added (constant 2005 US$) in Low & middle income in 2000 to that in 2004?
Your answer should be compact. 0.8. What is the ratio of the Value added (constant 2005 US$) in Greece in 2000 to that in 2004?
Offer a very short reply. 0.78. What is the ratio of the Value added (constant 2005 US$) of Guinea in 2000 to that in 2004?
Ensure brevity in your answer.  0.88. What is the ratio of the Value added (constant 2005 US$) in St. Vincent and the Grenadines in 2000 to that in 2004?
Keep it short and to the point. 0.79. What is the ratio of the Value added (constant 2005 US$) of Low & middle income in 2000 to that in 2005?
Your answer should be very brief. 0.74. What is the ratio of the Value added (constant 2005 US$) of Greece in 2000 to that in 2005?
Make the answer very short. 0.83. What is the ratio of the Value added (constant 2005 US$) of Guinea in 2000 to that in 2005?
Provide a short and direct response. 0.85. What is the ratio of the Value added (constant 2005 US$) in St. Vincent and the Grenadines in 2000 to that in 2005?
Offer a terse response. 0.77. What is the ratio of the Value added (constant 2005 US$) in Low & middle income in 2000 to that in 2006?
Make the answer very short. 0.68. What is the ratio of the Value added (constant 2005 US$) of Greece in 2000 to that in 2006?
Keep it short and to the point. 0.73. What is the ratio of the Value added (constant 2005 US$) of Guinea in 2000 to that in 2006?
Your answer should be compact. 0.83. What is the ratio of the Value added (constant 2005 US$) of St. Vincent and the Grenadines in 2000 to that in 2006?
Provide a short and direct response. 0.73. What is the ratio of the Value added (constant 2005 US$) in Low & middle income in 2001 to that in 2002?
Ensure brevity in your answer.  0.95. What is the ratio of the Value added (constant 2005 US$) in Greece in 2001 to that in 2002?
Ensure brevity in your answer.  0.96. What is the ratio of the Value added (constant 2005 US$) of Guinea in 2001 to that in 2002?
Ensure brevity in your answer.  0.95. What is the ratio of the Value added (constant 2005 US$) in St. Vincent and the Grenadines in 2001 to that in 2002?
Your response must be concise. 0.96. What is the ratio of the Value added (constant 2005 US$) in Low & middle income in 2001 to that in 2003?
Make the answer very short. 0.89. What is the ratio of the Value added (constant 2005 US$) of Greece in 2001 to that in 2003?
Make the answer very short. 0.86. What is the ratio of the Value added (constant 2005 US$) in Guinea in 2001 to that in 2003?
Make the answer very short. 0.95. What is the ratio of the Value added (constant 2005 US$) of St. Vincent and the Grenadines in 2001 to that in 2003?
Offer a very short reply. 0.85. What is the ratio of the Value added (constant 2005 US$) of Low & middle income in 2001 to that in 2004?
Your response must be concise. 0.82. What is the ratio of the Value added (constant 2005 US$) in Greece in 2001 to that in 2004?
Make the answer very short. 0.84. What is the ratio of the Value added (constant 2005 US$) of Guinea in 2001 to that in 2004?
Provide a succinct answer. 0.92. What is the ratio of the Value added (constant 2005 US$) of St. Vincent and the Grenadines in 2001 to that in 2004?
Your answer should be very brief. 0.81. What is the ratio of the Value added (constant 2005 US$) in Low & middle income in 2001 to that in 2005?
Give a very brief answer. 0.77. What is the ratio of the Value added (constant 2005 US$) in Greece in 2001 to that in 2005?
Offer a very short reply. 0.89. What is the ratio of the Value added (constant 2005 US$) of Guinea in 2001 to that in 2005?
Offer a very short reply. 0.89. What is the ratio of the Value added (constant 2005 US$) in St. Vincent and the Grenadines in 2001 to that in 2005?
Ensure brevity in your answer.  0.78. What is the ratio of the Value added (constant 2005 US$) of Low & middle income in 2001 to that in 2006?
Offer a terse response. 0.7. What is the ratio of the Value added (constant 2005 US$) in Greece in 2001 to that in 2006?
Offer a very short reply. 0.79. What is the ratio of the Value added (constant 2005 US$) of Guinea in 2001 to that in 2006?
Provide a succinct answer. 0.87. What is the ratio of the Value added (constant 2005 US$) in St. Vincent and the Grenadines in 2001 to that in 2006?
Give a very brief answer. 0.74. What is the ratio of the Value added (constant 2005 US$) of Low & middle income in 2002 to that in 2003?
Provide a short and direct response. 0.94. What is the ratio of the Value added (constant 2005 US$) of Greece in 2002 to that in 2003?
Ensure brevity in your answer.  0.9. What is the ratio of the Value added (constant 2005 US$) of Guinea in 2002 to that in 2003?
Offer a terse response. 1. What is the ratio of the Value added (constant 2005 US$) of St. Vincent and the Grenadines in 2002 to that in 2003?
Keep it short and to the point. 0.88. What is the ratio of the Value added (constant 2005 US$) in Low & middle income in 2002 to that in 2004?
Offer a very short reply. 0.86. What is the ratio of the Value added (constant 2005 US$) of Greece in 2002 to that in 2004?
Keep it short and to the point. 0.88. What is the ratio of the Value added (constant 2005 US$) in Guinea in 2002 to that in 2004?
Provide a short and direct response. 0.97. What is the ratio of the Value added (constant 2005 US$) of St. Vincent and the Grenadines in 2002 to that in 2004?
Give a very brief answer. 0.83. What is the ratio of the Value added (constant 2005 US$) in Low & middle income in 2002 to that in 2005?
Provide a succinct answer. 0.8. What is the ratio of the Value added (constant 2005 US$) of Greece in 2002 to that in 2005?
Provide a short and direct response. 0.93. What is the ratio of the Value added (constant 2005 US$) in Guinea in 2002 to that in 2005?
Make the answer very short. 0.94. What is the ratio of the Value added (constant 2005 US$) in St. Vincent and the Grenadines in 2002 to that in 2005?
Offer a very short reply. 0.81. What is the ratio of the Value added (constant 2005 US$) of Low & middle income in 2002 to that in 2006?
Ensure brevity in your answer.  0.74. What is the ratio of the Value added (constant 2005 US$) in Greece in 2002 to that in 2006?
Provide a short and direct response. 0.82. What is the ratio of the Value added (constant 2005 US$) of Guinea in 2002 to that in 2006?
Give a very brief answer. 0.91. What is the ratio of the Value added (constant 2005 US$) of St. Vincent and the Grenadines in 2002 to that in 2006?
Your answer should be very brief. 0.77. What is the ratio of the Value added (constant 2005 US$) in Low & middle income in 2003 to that in 2004?
Offer a very short reply. 0.92. What is the ratio of the Value added (constant 2005 US$) of Greece in 2003 to that in 2004?
Your answer should be very brief. 0.97. What is the ratio of the Value added (constant 2005 US$) of Guinea in 2003 to that in 2004?
Your answer should be compact. 0.97. What is the ratio of the Value added (constant 2005 US$) in St. Vincent and the Grenadines in 2003 to that in 2004?
Your response must be concise. 0.95. What is the ratio of the Value added (constant 2005 US$) of Low & middle income in 2003 to that in 2005?
Make the answer very short. 0.86. What is the ratio of the Value added (constant 2005 US$) in Greece in 2003 to that in 2005?
Offer a very short reply. 1.03. What is the ratio of the Value added (constant 2005 US$) of Guinea in 2003 to that in 2005?
Make the answer very short. 0.94. What is the ratio of the Value added (constant 2005 US$) in St. Vincent and the Grenadines in 2003 to that in 2005?
Ensure brevity in your answer.  0.92. What is the ratio of the Value added (constant 2005 US$) of Low & middle income in 2003 to that in 2006?
Offer a terse response. 0.79. What is the ratio of the Value added (constant 2005 US$) of Greece in 2003 to that in 2006?
Ensure brevity in your answer.  0.91. What is the ratio of the Value added (constant 2005 US$) in Guinea in 2003 to that in 2006?
Your response must be concise. 0.91. What is the ratio of the Value added (constant 2005 US$) in St. Vincent and the Grenadines in 2003 to that in 2006?
Give a very brief answer. 0.87. What is the ratio of the Value added (constant 2005 US$) of Low & middle income in 2004 to that in 2005?
Make the answer very short. 0.93. What is the ratio of the Value added (constant 2005 US$) in Greece in 2004 to that in 2005?
Your answer should be very brief. 1.06. What is the ratio of the Value added (constant 2005 US$) in Guinea in 2004 to that in 2005?
Your answer should be compact. 0.96. What is the ratio of the Value added (constant 2005 US$) in St. Vincent and the Grenadines in 2004 to that in 2005?
Make the answer very short. 0.97. What is the ratio of the Value added (constant 2005 US$) of Low & middle income in 2004 to that in 2006?
Provide a short and direct response. 0.86. What is the ratio of the Value added (constant 2005 US$) of Greece in 2004 to that in 2006?
Give a very brief answer. 0.94. What is the ratio of the Value added (constant 2005 US$) of Guinea in 2004 to that in 2006?
Keep it short and to the point. 0.94. What is the ratio of the Value added (constant 2005 US$) in St. Vincent and the Grenadines in 2004 to that in 2006?
Your response must be concise. 0.93. What is the ratio of the Value added (constant 2005 US$) in Low & middle income in 2005 to that in 2006?
Offer a very short reply. 0.92. What is the ratio of the Value added (constant 2005 US$) of Greece in 2005 to that in 2006?
Make the answer very short. 0.88. What is the ratio of the Value added (constant 2005 US$) of Guinea in 2005 to that in 2006?
Ensure brevity in your answer.  0.98. What is the ratio of the Value added (constant 2005 US$) in St. Vincent and the Grenadines in 2005 to that in 2006?
Offer a terse response. 0.96. What is the difference between the highest and the second highest Value added (constant 2005 US$) in Low & middle income?
Make the answer very short. 2.70e+11. What is the difference between the highest and the second highest Value added (constant 2005 US$) in Greece?
Offer a very short reply. 3.09e+09. What is the difference between the highest and the second highest Value added (constant 2005 US$) in Guinea?
Your response must be concise. 2.14e+07. What is the difference between the highest and the second highest Value added (constant 2005 US$) in St. Vincent and the Grenadines?
Ensure brevity in your answer.  4.23e+06. What is the difference between the highest and the lowest Value added (constant 2005 US$) of Low & middle income?
Your answer should be very brief. 1.20e+12. What is the difference between the highest and the lowest Value added (constant 2005 US$) of Greece?
Keep it short and to the point. 1.44e+1. What is the difference between the highest and the lowest Value added (constant 2005 US$) in Guinea?
Make the answer very short. 2.00e+08. What is the difference between the highest and the lowest Value added (constant 2005 US$) of St. Vincent and the Grenadines?
Offer a very short reply. 2.52e+07. 